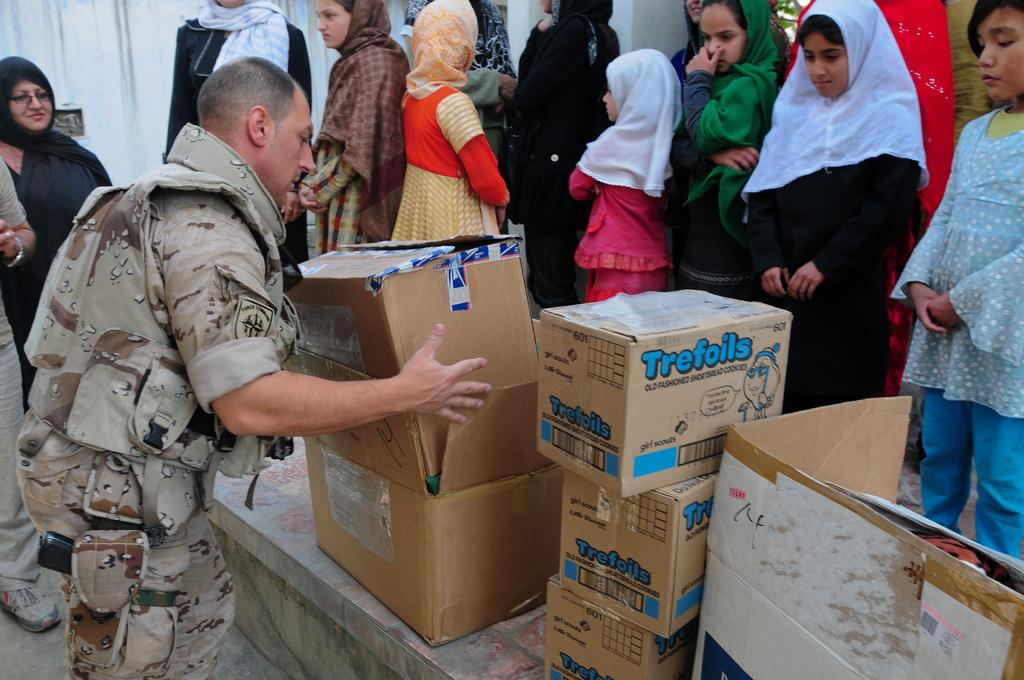What is the person in the image wearing? The person is wearing a brown color uniform. What is the person holding in the image? The person is holding cardboard boxes. Can you describe the background of the image? The background includes a wall with a white color. Are there any other people visible in the image? Yes, there are other persons standing in the background of the image. What type of discussion is taking place in the image? There is no discussion taking place in the image; it only shows a person holding cardboard boxes and other persons standing in the background. 